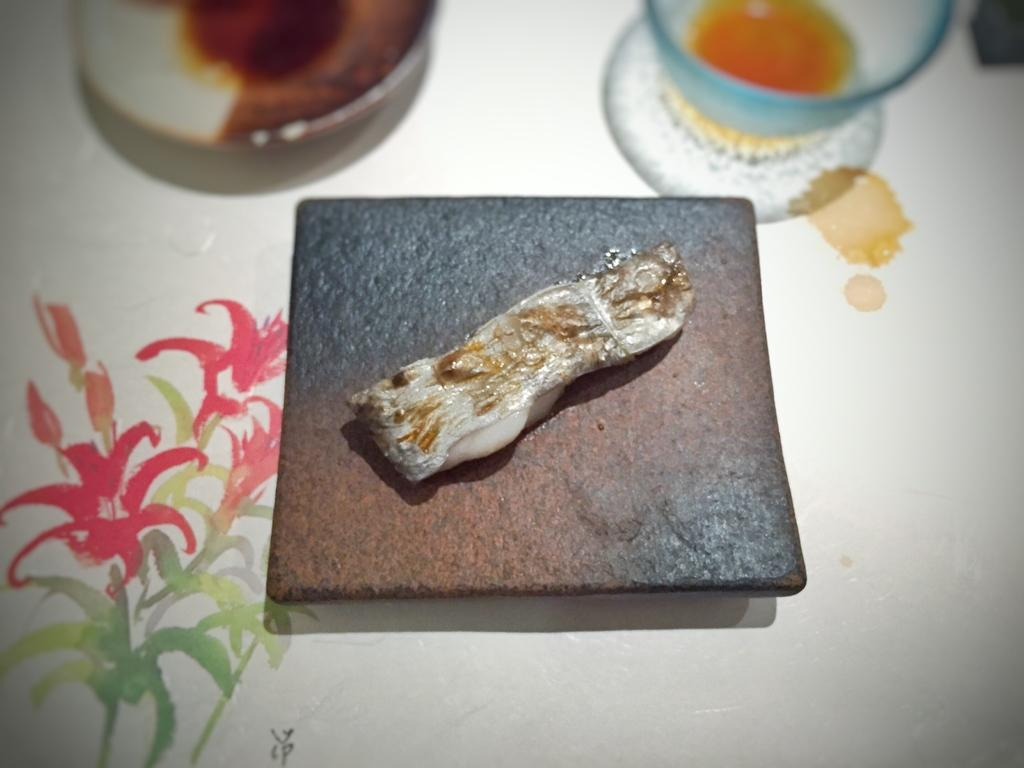What objects can be seen on a surface in the painting? There is a plate and a cup in the painting. Can you describe the object on a platform in the painting? Unfortunately, the facts provided do not give enough information to describe the object on the platform. What type of surface might the plate and cup be placed on? The facts provided do not give enough information to determine the type of surface the plate and cup are placed on. What type of lumber is used to construct the zipper in the painting? There is no mention of lumber or a zipper in the painting, so this question cannot be answered. 